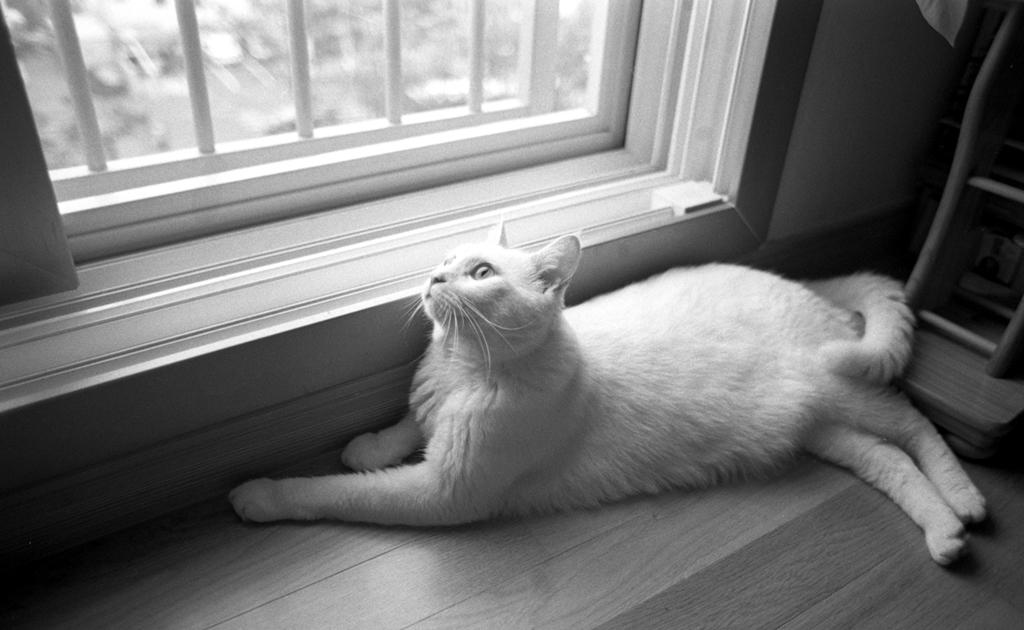What animal is present in the image? There is a cat in the image. Where is the cat located in the image? The cat is sitting on the floor. What can be seen through the window in the image? The facts provided do not mention anything visible through the window. What is the color scheme of the image? The image is black and white in color. What type of growth can be seen on the cat's fur in the image? There is no growth visible on the cat's fur in the image, as it is a black and white image and growth would not be visible in this color scheme. 